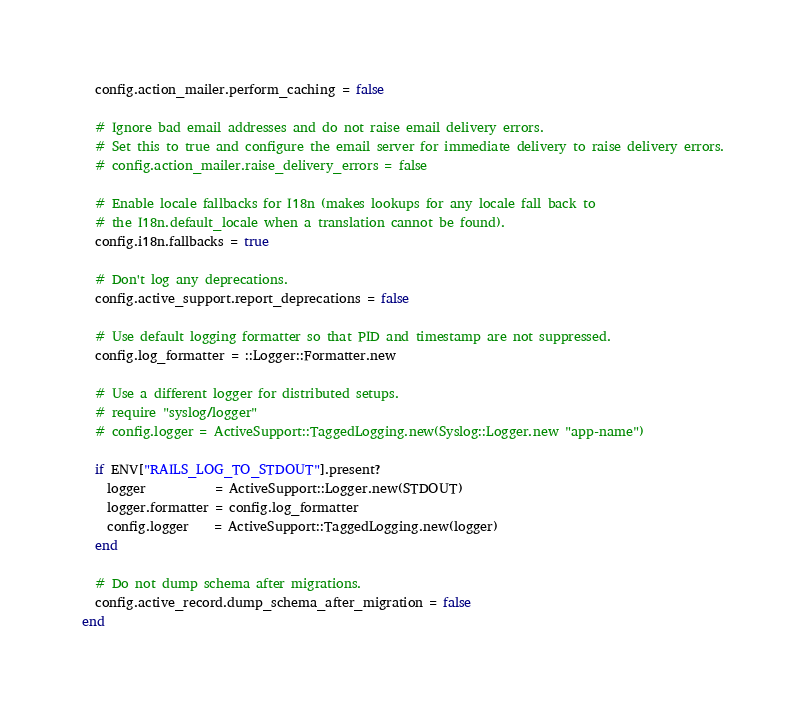Convert code to text. <code><loc_0><loc_0><loc_500><loc_500><_Ruby_>
  config.action_mailer.perform_caching = false

  # Ignore bad email addresses and do not raise email delivery errors.
  # Set this to true and configure the email server for immediate delivery to raise delivery errors.
  # config.action_mailer.raise_delivery_errors = false

  # Enable locale fallbacks for I18n (makes lookups for any locale fall back to
  # the I18n.default_locale when a translation cannot be found).
  config.i18n.fallbacks = true

  # Don't log any deprecations.
  config.active_support.report_deprecations = false

  # Use default logging formatter so that PID and timestamp are not suppressed.
  config.log_formatter = ::Logger::Formatter.new

  # Use a different logger for distributed setups.
  # require "syslog/logger"
  # config.logger = ActiveSupport::TaggedLogging.new(Syslog::Logger.new "app-name")

  if ENV["RAILS_LOG_TO_STDOUT"].present?
    logger           = ActiveSupport::Logger.new(STDOUT)
    logger.formatter = config.log_formatter
    config.logger    = ActiveSupport::TaggedLogging.new(logger)
  end

  # Do not dump schema after migrations.
  config.active_record.dump_schema_after_migration = false
end
</code> 